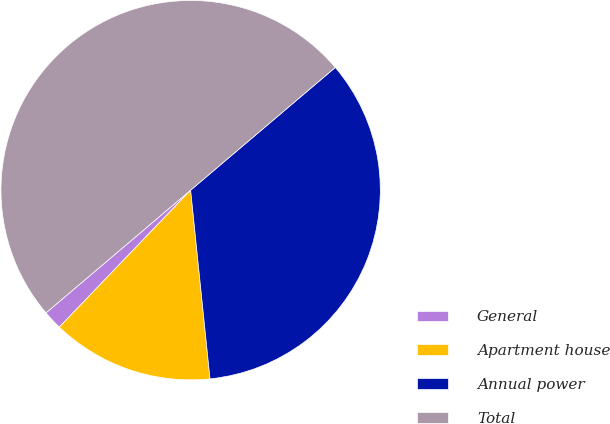<chart> <loc_0><loc_0><loc_500><loc_500><pie_chart><fcel>General<fcel>Apartment house<fcel>Annual power<fcel>Total<nl><fcel>1.64%<fcel>13.79%<fcel>34.57%<fcel>50.0%<nl></chart> 